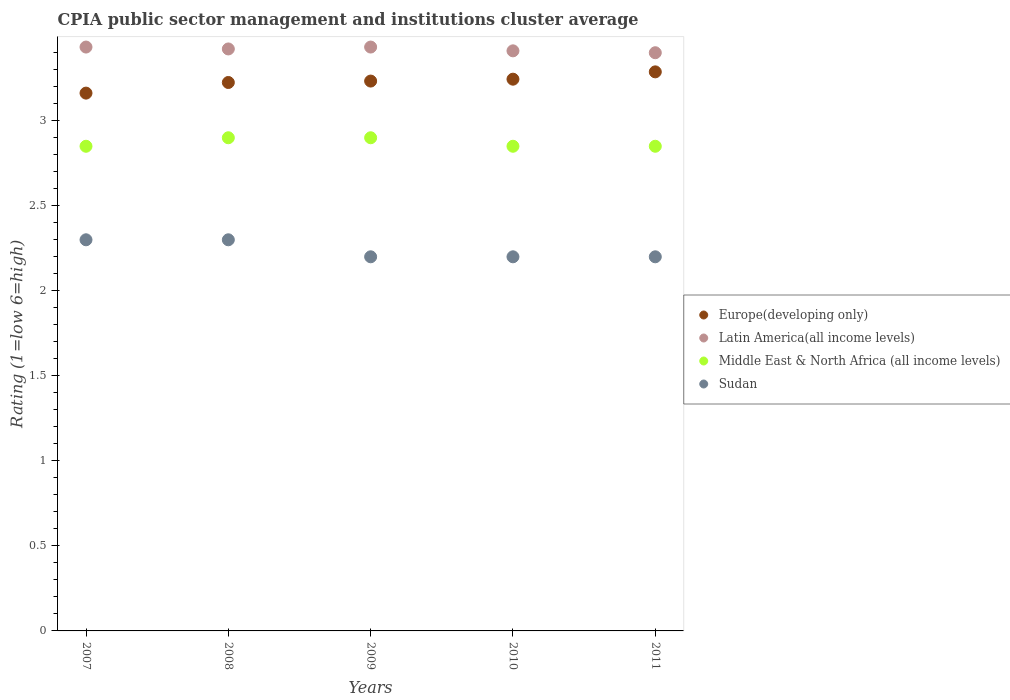How many different coloured dotlines are there?
Offer a very short reply. 4. Is the number of dotlines equal to the number of legend labels?
Your answer should be compact. Yes. Across all years, what is the maximum CPIA rating in Europe(developing only)?
Offer a very short reply. 3.29. Across all years, what is the minimum CPIA rating in Middle East & North Africa (all income levels)?
Make the answer very short. 2.85. In which year was the CPIA rating in Europe(developing only) maximum?
Provide a succinct answer. 2011. In which year was the CPIA rating in Latin America(all income levels) minimum?
Your answer should be very brief. 2011. What is the total CPIA rating in Sudan in the graph?
Your response must be concise. 11.2. What is the difference between the CPIA rating in Middle East & North Africa (all income levels) in 2009 and that in 2011?
Offer a terse response. 0.05. What is the difference between the CPIA rating in Middle East & North Africa (all income levels) in 2008 and the CPIA rating in Sudan in 2010?
Provide a succinct answer. 0.7. What is the average CPIA rating in Sudan per year?
Provide a succinct answer. 2.24. In the year 2009, what is the difference between the CPIA rating in Latin America(all income levels) and CPIA rating in Europe(developing only)?
Ensure brevity in your answer.  0.2. In how many years, is the CPIA rating in Middle East & North Africa (all income levels) greater than 2.7?
Keep it short and to the point. 5. What is the ratio of the CPIA rating in Sudan in 2007 to that in 2011?
Offer a very short reply. 1.05. Is the difference between the CPIA rating in Latin America(all income levels) in 2007 and 2010 greater than the difference between the CPIA rating in Europe(developing only) in 2007 and 2010?
Give a very brief answer. Yes. What is the difference between the highest and the second highest CPIA rating in Europe(developing only)?
Provide a short and direct response. 0.04. What is the difference between the highest and the lowest CPIA rating in Middle East & North Africa (all income levels)?
Ensure brevity in your answer.  0.05. Is it the case that in every year, the sum of the CPIA rating in Sudan and CPIA rating in Latin America(all income levels)  is greater than the sum of CPIA rating in Middle East & North Africa (all income levels) and CPIA rating in Europe(developing only)?
Provide a succinct answer. No. How many dotlines are there?
Your response must be concise. 4. How many years are there in the graph?
Give a very brief answer. 5. What is the difference between two consecutive major ticks on the Y-axis?
Your answer should be very brief. 0.5. Are the values on the major ticks of Y-axis written in scientific E-notation?
Provide a succinct answer. No. Does the graph contain grids?
Offer a terse response. No. Where does the legend appear in the graph?
Ensure brevity in your answer.  Center right. What is the title of the graph?
Give a very brief answer. CPIA public sector management and institutions cluster average. Does "Netherlands" appear as one of the legend labels in the graph?
Provide a short and direct response. No. What is the label or title of the X-axis?
Ensure brevity in your answer.  Years. What is the Rating (1=low 6=high) of Europe(developing only) in 2007?
Ensure brevity in your answer.  3.16. What is the Rating (1=low 6=high) in Latin America(all income levels) in 2007?
Keep it short and to the point. 3.43. What is the Rating (1=low 6=high) in Middle East & North Africa (all income levels) in 2007?
Give a very brief answer. 2.85. What is the Rating (1=low 6=high) in Sudan in 2007?
Ensure brevity in your answer.  2.3. What is the Rating (1=low 6=high) in Europe(developing only) in 2008?
Make the answer very short. 3.23. What is the Rating (1=low 6=high) in Latin America(all income levels) in 2008?
Make the answer very short. 3.42. What is the Rating (1=low 6=high) in Sudan in 2008?
Ensure brevity in your answer.  2.3. What is the Rating (1=low 6=high) in Europe(developing only) in 2009?
Your answer should be very brief. 3.23. What is the Rating (1=low 6=high) in Latin America(all income levels) in 2009?
Give a very brief answer. 3.43. What is the Rating (1=low 6=high) of Middle East & North Africa (all income levels) in 2009?
Your answer should be very brief. 2.9. What is the Rating (1=low 6=high) in Sudan in 2009?
Ensure brevity in your answer.  2.2. What is the Rating (1=low 6=high) in Europe(developing only) in 2010?
Your answer should be compact. 3.24. What is the Rating (1=low 6=high) in Latin America(all income levels) in 2010?
Your answer should be compact. 3.41. What is the Rating (1=low 6=high) of Middle East & North Africa (all income levels) in 2010?
Give a very brief answer. 2.85. What is the Rating (1=low 6=high) of Europe(developing only) in 2011?
Give a very brief answer. 3.29. What is the Rating (1=low 6=high) of Middle East & North Africa (all income levels) in 2011?
Your answer should be compact. 2.85. Across all years, what is the maximum Rating (1=low 6=high) of Europe(developing only)?
Offer a very short reply. 3.29. Across all years, what is the maximum Rating (1=low 6=high) of Latin America(all income levels)?
Your answer should be compact. 3.43. Across all years, what is the minimum Rating (1=low 6=high) of Europe(developing only)?
Give a very brief answer. 3.16. Across all years, what is the minimum Rating (1=low 6=high) in Latin America(all income levels)?
Offer a very short reply. 3.4. Across all years, what is the minimum Rating (1=low 6=high) in Middle East & North Africa (all income levels)?
Your answer should be very brief. 2.85. What is the total Rating (1=low 6=high) of Europe(developing only) in the graph?
Offer a terse response. 16.15. What is the total Rating (1=low 6=high) of Latin America(all income levels) in the graph?
Your response must be concise. 17.1. What is the total Rating (1=low 6=high) in Middle East & North Africa (all income levels) in the graph?
Offer a very short reply. 14.35. What is the total Rating (1=low 6=high) in Sudan in the graph?
Offer a terse response. 11.2. What is the difference between the Rating (1=low 6=high) in Europe(developing only) in 2007 and that in 2008?
Offer a terse response. -0.06. What is the difference between the Rating (1=low 6=high) in Latin America(all income levels) in 2007 and that in 2008?
Offer a very short reply. 0.01. What is the difference between the Rating (1=low 6=high) of Middle East & North Africa (all income levels) in 2007 and that in 2008?
Offer a very short reply. -0.05. What is the difference between the Rating (1=low 6=high) in Sudan in 2007 and that in 2008?
Provide a short and direct response. 0. What is the difference between the Rating (1=low 6=high) in Europe(developing only) in 2007 and that in 2009?
Your answer should be compact. -0.07. What is the difference between the Rating (1=low 6=high) in Middle East & North Africa (all income levels) in 2007 and that in 2009?
Your response must be concise. -0.05. What is the difference between the Rating (1=low 6=high) of Europe(developing only) in 2007 and that in 2010?
Keep it short and to the point. -0.08. What is the difference between the Rating (1=low 6=high) of Latin America(all income levels) in 2007 and that in 2010?
Give a very brief answer. 0.02. What is the difference between the Rating (1=low 6=high) in Middle East & North Africa (all income levels) in 2007 and that in 2010?
Your answer should be compact. 0. What is the difference between the Rating (1=low 6=high) in Sudan in 2007 and that in 2010?
Ensure brevity in your answer.  0.1. What is the difference between the Rating (1=low 6=high) of Europe(developing only) in 2007 and that in 2011?
Your response must be concise. -0.12. What is the difference between the Rating (1=low 6=high) of Latin America(all income levels) in 2007 and that in 2011?
Provide a short and direct response. 0.03. What is the difference between the Rating (1=low 6=high) of Sudan in 2007 and that in 2011?
Make the answer very short. 0.1. What is the difference between the Rating (1=low 6=high) of Europe(developing only) in 2008 and that in 2009?
Your answer should be compact. -0.01. What is the difference between the Rating (1=low 6=high) of Latin America(all income levels) in 2008 and that in 2009?
Offer a very short reply. -0.01. What is the difference between the Rating (1=low 6=high) of Middle East & North Africa (all income levels) in 2008 and that in 2009?
Keep it short and to the point. 0. What is the difference between the Rating (1=low 6=high) of Sudan in 2008 and that in 2009?
Your response must be concise. 0.1. What is the difference between the Rating (1=low 6=high) in Europe(developing only) in 2008 and that in 2010?
Give a very brief answer. -0.02. What is the difference between the Rating (1=low 6=high) in Latin America(all income levels) in 2008 and that in 2010?
Your answer should be very brief. 0.01. What is the difference between the Rating (1=low 6=high) in Middle East & North Africa (all income levels) in 2008 and that in 2010?
Keep it short and to the point. 0.05. What is the difference between the Rating (1=low 6=high) of Europe(developing only) in 2008 and that in 2011?
Your response must be concise. -0.06. What is the difference between the Rating (1=low 6=high) of Latin America(all income levels) in 2008 and that in 2011?
Your answer should be compact. 0.02. What is the difference between the Rating (1=low 6=high) in Middle East & North Africa (all income levels) in 2008 and that in 2011?
Your answer should be compact. 0.05. What is the difference between the Rating (1=low 6=high) in Sudan in 2008 and that in 2011?
Make the answer very short. 0.1. What is the difference between the Rating (1=low 6=high) in Europe(developing only) in 2009 and that in 2010?
Make the answer very short. -0.01. What is the difference between the Rating (1=low 6=high) of Latin America(all income levels) in 2009 and that in 2010?
Offer a very short reply. 0.02. What is the difference between the Rating (1=low 6=high) of Sudan in 2009 and that in 2010?
Your answer should be compact. 0. What is the difference between the Rating (1=low 6=high) in Europe(developing only) in 2009 and that in 2011?
Keep it short and to the point. -0.05. What is the difference between the Rating (1=low 6=high) of Latin America(all income levels) in 2009 and that in 2011?
Your answer should be very brief. 0.03. What is the difference between the Rating (1=low 6=high) in Middle East & North Africa (all income levels) in 2009 and that in 2011?
Offer a very short reply. 0.05. What is the difference between the Rating (1=low 6=high) in Sudan in 2009 and that in 2011?
Your response must be concise. 0. What is the difference between the Rating (1=low 6=high) of Europe(developing only) in 2010 and that in 2011?
Provide a succinct answer. -0.04. What is the difference between the Rating (1=low 6=high) of Latin America(all income levels) in 2010 and that in 2011?
Provide a succinct answer. 0.01. What is the difference between the Rating (1=low 6=high) in Europe(developing only) in 2007 and the Rating (1=low 6=high) in Latin America(all income levels) in 2008?
Your answer should be very brief. -0.26. What is the difference between the Rating (1=low 6=high) of Europe(developing only) in 2007 and the Rating (1=low 6=high) of Middle East & North Africa (all income levels) in 2008?
Your answer should be compact. 0.26. What is the difference between the Rating (1=low 6=high) in Europe(developing only) in 2007 and the Rating (1=low 6=high) in Sudan in 2008?
Make the answer very short. 0.86. What is the difference between the Rating (1=low 6=high) in Latin America(all income levels) in 2007 and the Rating (1=low 6=high) in Middle East & North Africa (all income levels) in 2008?
Provide a succinct answer. 0.53. What is the difference between the Rating (1=low 6=high) of Latin America(all income levels) in 2007 and the Rating (1=low 6=high) of Sudan in 2008?
Your answer should be very brief. 1.13. What is the difference between the Rating (1=low 6=high) in Middle East & North Africa (all income levels) in 2007 and the Rating (1=low 6=high) in Sudan in 2008?
Offer a terse response. 0.55. What is the difference between the Rating (1=low 6=high) in Europe(developing only) in 2007 and the Rating (1=low 6=high) in Latin America(all income levels) in 2009?
Ensure brevity in your answer.  -0.27. What is the difference between the Rating (1=low 6=high) in Europe(developing only) in 2007 and the Rating (1=low 6=high) in Middle East & North Africa (all income levels) in 2009?
Ensure brevity in your answer.  0.26. What is the difference between the Rating (1=low 6=high) of Europe(developing only) in 2007 and the Rating (1=low 6=high) of Sudan in 2009?
Keep it short and to the point. 0.96. What is the difference between the Rating (1=low 6=high) in Latin America(all income levels) in 2007 and the Rating (1=low 6=high) in Middle East & North Africa (all income levels) in 2009?
Provide a succinct answer. 0.53. What is the difference between the Rating (1=low 6=high) in Latin America(all income levels) in 2007 and the Rating (1=low 6=high) in Sudan in 2009?
Give a very brief answer. 1.23. What is the difference between the Rating (1=low 6=high) in Middle East & North Africa (all income levels) in 2007 and the Rating (1=low 6=high) in Sudan in 2009?
Provide a succinct answer. 0.65. What is the difference between the Rating (1=low 6=high) in Europe(developing only) in 2007 and the Rating (1=low 6=high) in Latin America(all income levels) in 2010?
Provide a short and direct response. -0.25. What is the difference between the Rating (1=low 6=high) of Europe(developing only) in 2007 and the Rating (1=low 6=high) of Middle East & North Africa (all income levels) in 2010?
Your response must be concise. 0.31. What is the difference between the Rating (1=low 6=high) of Europe(developing only) in 2007 and the Rating (1=low 6=high) of Sudan in 2010?
Offer a terse response. 0.96. What is the difference between the Rating (1=low 6=high) in Latin America(all income levels) in 2007 and the Rating (1=low 6=high) in Middle East & North Africa (all income levels) in 2010?
Your answer should be compact. 0.58. What is the difference between the Rating (1=low 6=high) in Latin America(all income levels) in 2007 and the Rating (1=low 6=high) in Sudan in 2010?
Provide a succinct answer. 1.23. What is the difference between the Rating (1=low 6=high) of Middle East & North Africa (all income levels) in 2007 and the Rating (1=low 6=high) of Sudan in 2010?
Keep it short and to the point. 0.65. What is the difference between the Rating (1=low 6=high) in Europe(developing only) in 2007 and the Rating (1=low 6=high) in Latin America(all income levels) in 2011?
Keep it short and to the point. -0.24. What is the difference between the Rating (1=low 6=high) of Europe(developing only) in 2007 and the Rating (1=low 6=high) of Middle East & North Africa (all income levels) in 2011?
Your answer should be very brief. 0.31. What is the difference between the Rating (1=low 6=high) in Europe(developing only) in 2007 and the Rating (1=low 6=high) in Sudan in 2011?
Provide a short and direct response. 0.96. What is the difference between the Rating (1=low 6=high) of Latin America(all income levels) in 2007 and the Rating (1=low 6=high) of Middle East & North Africa (all income levels) in 2011?
Your answer should be very brief. 0.58. What is the difference between the Rating (1=low 6=high) in Latin America(all income levels) in 2007 and the Rating (1=low 6=high) in Sudan in 2011?
Your response must be concise. 1.23. What is the difference between the Rating (1=low 6=high) of Middle East & North Africa (all income levels) in 2007 and the Rating (1=low 6=high) of Sudan in 2011?
Give a very brief answer. 0.65. What is the difference between the Rating (1=low 6=high) of Europe(developing only) in 2008 and the Rating (1=low 6=high) of Latin America(all income levels) in 2009?
Your response must be concise. -0.21. What is the difference between the Rating (1=low 6=high) in Europe(developing only) in 2008 and the Rating (1=low 6=high) in Middle East & North Africa (all income levels) in 2009?
Provide a succinct answer. 0.33. What is the difference between the Rating (1=low 6=high) of Europe(developing only) in 2008 and the Rating (1=low 6=high) of Sudan in 2009?
Your response must be concise. 1.02. What is the difference between the Rating (1=low 6=high) in Latin America(all income levels) in 2008 and the Rating (1=low 6=high) in Middle East & North Africa (all income levels) in 2009?
Your response must be concise. 0.52. What is the difference between the Rating (1=low 6=high) in Latin America(all income levels) in 2008 and the Rating (1=low 6=high) in Sudan in 2009?
Give a very brief answer. 1.22. What is the difference between the Rating (1=low 6=high) in Middle East & North Africa (all income levels) in 2008 and the Rating (1=low 6=high) in Sudan in 2009?
Offer a very short reply. 0.7. What is the difference between the Rating (1=low 6=high) of Europe(developing only) in 2008 and the Rating (1=low 6=high) of Latin America(all income levels) in 2010?
Provide a succinct answer. -0.19. What is the difference between the Rating (1=low 6=high) of Latin America(all income levels) in 2008 and the Rating (1=low 6=high) of Middle East & North Africa (all income levels) in 2010?
Provide a succinct answer. 0.57. What is the difference between the Rating (1=low 6=high) in Latin America(all income levels) in 2008 and the Rating (1=low 6=high) in Sudan in 2010?
Provide a short and direct response. 1.22. What is the difference between the Rating (1=low 6=high) in Europe(developing only) in 2008 and the Rating (1=low 6=high) in Latin America(all income levels) in 2011?
Offer a terse response. -0.17. What is the difference between the Rating (1=low 6=high) in Europe(developing only) in 2008 and the Rating (1=low 6=high) in Middle East & North Africa (all income levels) in 2011?
Make the answer very short. 0.38. What is the difference between the Rating (1=low 6=high) of Latin America(all income levels) in 2008 and the Rating (1=low 6=high) of Middle East & North Africa (all income levels) in 2011?
Keep it short and to the point. 0.57. What is the difference between the Rating (1=low 6=high) in Latin America(all income levels) in 2008 and the Rating (1=low 6=high) in Sudan in 2011?
Offer a very short reply. 1.22. What is the difference between the Rating (1=low 6=high) of Middle East & North Africa (all income levels) in 2008 and the Rating (1=low 6=high) of Sudan in 2011?
Ensure brevity in your answer.  0.7. What is the difference between the Rating (1=low 6=high) in Europe(developing only) in 2009 and the Rating (1=low 6=high) in Latin America(all income levels) in 2010?
Provide a succinct answer. -0.18. What is the difference between the Rating (1=low 6=high) of Europe(developing only) in 2009 and the Rating (1=low 6=high) of Middle East & North Africa (all income levels) in 2010?
Your response must be concise. 0.38. What is the difference between the Rating (1=low 6=high) of Europe(developing only) in 2009 and the Rating (1=low 6=high) of Sudan in 2010?
Your answer should be very brief. 1.03. What is the difference between the Rating (1=low 6=high) of Latin America(all income levels) in 2009 and the Rating (1=low 6=high) of Middle East & North Africa (all income levels) in 2010?
Provide a succinct answer. 0.58. What is the difference between the Rating (1=low 6=high) of Latin America(all income levels) in 2009 and the Rating (1=low 6=high) of Sudan in 2010?
Give a very brief answer. 1.23. What is the difference between the Rating (1=low 6=high) of Europe(developing only) in 2009 and the Rating (1=low 6=high) of Latin America(all income levels) in 2011?
Keep it short and to the point. -0.17. What is the difference between the Rating (1=low 6=high) of Europe(developing only) in 2009 and the Rating (1=low 6=high) of Middle East & North Africa (all income levels) in 2011?
Provide a succinct answer. 0.38. What is the difference between the Rating (1=low 6=high) of Europe(developing only) in 2009 and the Rating (1=low 6=high) of Sudan in 2011?
Ensure brevity in your answer.  1.03. What is the difference between the Rating (1=low 6=high) of Latin America(all income levels) in 2009 and the Rating (1=low 6=high) of Middle East & North Africa (all income levels) in 2011?
Give a very brief answer. 0.58. What is the difference between the Rating (1=low 6=high) of Latin America(all income levels) in 2009 and the Rating (1=low 6=high) of Sudan in 2011?
Make the answer very short. 1.23. What is the difference between the Rating (1=low 6=high) of Middle East & North Africa (all income levels) in 2009 and the Rating (1=low 6=high) of Sudan in 2011?
Provide a succinct answer. 0.7. What is the difference between the Rating (1=low 6=high) of Europe(developing only) in 2010 and the Rating (1=low 6=high) of Latin America(all income levels) in 2011?
Offer a terse response. -0.16. What is the difference between the Rating (1=low 6=high) of Europe(developing only) in 2010 and the Rating (1=low 6=high) of Middle East & North Africa (all income levels) in 2011?
Provide a succinct answer. 0.39. What is the difference between the Rating (1=low 6=high) of Europe(developing only) in 2010 and the Rating (1=low 6=high) of Sudan in 2011?
Your answer should be very brief. 1.04. What is the difference between the Rating (1=low 6=high) of Latin America(all income levels) in 2010 and the Rating (1=low 6=high) of Middle East & North Africa (all income levels) in 2011?
Provide a succinct answer. 0.56. What is the difference between the Rating (1=low 6=high) in Latin America(all income levels) in 2010 and the Rating (1=low 6=high) in Sudan in 2011?
Provide a succinct answer. 1.21. What is the difference between the Rating (1=low 6=high) in Middle East & North Africa (all income levels) in 2010 and the Rating (1=low 6=high) in Sudan in 2011?
Keep it short and to the point. 0.65. What is the average Rating (1=low 6=high) of Europe(developing only) per year?
Give a very brief answer. 3.23. What is the average Rating (1=low 6=high) of Latin America(all income levels) per year?
Give a very brief answer. 3.42. What is the average Rating (1=low 6=high) of Middle East & North Africa (all income levels) per year?
Give a very brief answer. 2.87. What is the average Rating (1=low 6=high) in Sudan per year?
Keep it short and to the point. 2.24. In the year 2007, what is the difference between the Rating (1=low 6=high) in Europe(developing only) and Rating (1=low 6=high) in Latin America(all income levels)?
Keep it short and to the point. -0.27. In the year 2007, what is the difference between the Rating (1=low 6=high) of Europe(developing only) and Rating (1=low 6=high) of Middle East & North Africa (all income levels)?
Offer a terse response. 0.31. In the year 2007, what is the difference between the Rating (1=low 6=high) of Europe(developing only) and Rating (1=low 6=high) of Sudan?
Offer a terse response. 0.86. In the year 2007, what is the difference between the Rating (1=low 6=high) in Latin America(all income levels) and Rating (1=low 6=high) in Middle East & North Africa (all income levels)?
Ensure brevity in your answer.  0.58. In the year 2007, what is the difference between the Rating (1=low 6=high) in Latin America(all income levels) and Rating (1=low 6=high) in Sudan?
Offer a very short reply. 1.13. In the year 2007, what is the difference between the Rating (1=low 6=high) in Middle East & North Africa (all income levels) and Rating (1=low 6=high) in Sudan?
Offer a terse response. 0.55. In the year 2008, what is the difference between the Rating (1=low 6=high) of Europe(developing only) and Rating (1=low 6=high) of Latin America(all income levels)?
Your answer should be very brief. -0.2. In the year 2008, what is the difference between the Rating (1=low 6=high) in Europe(developing only) and Rating (1=low 6=high) in Middle East & North Africa (all income levels)?
Give a very brief answer. 0.33. In the year 2008, what is the difference between the Rating (1=low 6=high) of Europe(developing only) and Rating (1=low 6=high) of Sudan?
Keep it short and to the point. 0.93. In the year 2008, what is the difference between the Rating (1=low 6=high) of Latin America(all income levels) and Rating (1=low 6=high) of Middle East & North Africa (all income levels)?
Ensure brevity in your answer.  0.52. In the year 2008, what is the difference between the Rating (1=low 6=high) of Latin America(all income levels) and Rating (1=low 6=high) of Sudan?
Your response must be concise. 1.12. In the year 2009, what is the difference between the Rating (1=low 6=high) of Europe(developing only) and Rating (1=low 6=high) of Latin America(all income levels)?
Provide a short and direct response. -0.2. In the year 2009, what is the difference between the Rating (1=low 6=high) of Europe(developing only) and Rating (1=low 6=high) of Middle East & North Africa (all income levels)?
Provide a succinct answer. 0.33. In the year 2009, what is the difference between the Rating (1=low 6=high) in Europe(developing only) and Rating (1=low 6=high) in Sudan?
Offer a terse response. 1.03. In the year 2009, what is the difference between the Rating (1=low 6=high) in Latin America(all income levels) and Rating (1=low 6=high) in Middle East & North Africa (all income levels)?
Your answer should be very brief. 0.53. In the year 2009, what is the difference between the Rating (1=low 6=high) in Latin America(all income levels) and Rating (1=low 6=high) in Sudan?
Make the answer very short. 1.23. In the year 2009, what is the difference between the Rating (1=low 6=high) of Middle East & North Africa (all income levels) and Rating (1=low 6=high) of Sudan?
Your answer should be compact. 0.7. In the year 2010, what is the difference between the Rating (1=low 6=high) in Europe(developing only) and Rating (1=low 6=high) in Latin America(all income levels)?
Offer a terse response. -0.17. In the year 2010, what is the difference between the Rating (1=low 6=high) of Europe(developing only) and Rating (1=low 6=high) of Middle East & North Africa (all income levels)?
Your answer should be compact. 0.39. In the year 2010, what is the difference between the Rating (1=low 6=high) of Europe(developing only) and Rating (1=low 6=high) of Sudan?
Your answer should be very brief. 1.04. In the year 2010, what is the difference between the Rating (1=low 6=high) of Latin America(all income levels) and Rating (1=low 6=high) of Middle East & North Africa (all income levels)?
Provide a short and direct response. 0.56. In the year 2010, what is the difference between the Rating (1=low 6=high) of Latin America(all income levels) and Rating (1=low 6=high) of Sudan?
Keep it short and to the point. 1.21. In the year 2010, what is the difference between the Rating (1=low 6=high) in Middle East & North Africa (all income levels) and Rating (1=low 6=high) in Sudan?
Ensure brevity in your answer.  0.65. In the year 2011, what is the difference between the Rating (1=low 6=high) in Europe(developing only) and Rating (1=low 6=high) in Latin America(all income levels)?
Provide a succinct answer. -0.11. In the year 2011, what is the difference between the Rating (1=low 6=high) of Europe(developing only) and Rating (1=low 6=high) of Middle East & North Africa (all income levels)?
Provide a succinct answer. 0.44. In the year 2011, what is the difference between the Rating (1=low 6=high) in Europe(developing only) and Rating (1=low 6=high) in Sudan?
Your answer should be very brief. 1.09. In the year 2011, what is the difference between the Rating (1=low 6=high) in Latin America(all income levels) and Rating (1=low 6=high) in Middle East & North Africa (all income levels)?
Keep it short and to the point. 0.55. In the year 2011, what is the difference between the Rating (1=low 6=high) of Latin America(all income levels) and Rating (1=low 6=high) of Sudan?
Your answer should be very brief. 1.2. In the year 2011, what is the difference between the Rating (1=low 6=high) of Middle East & North Africa (all income levels) and Rating (1=low 6=high) of Sudan?
Offer a very short reply. 0.65. What is the ratio of the Rating (1=low 6=high) of Europe(developing only) in 2007 to that in 2008?
Provide a short and direct response. 0.98. What is the ratio of the Rating (1=low 6=high) of Latin America(all income levels) in 2007 to that in 2008?
Your answer should be compact. 1. What is the ratio of the Rating (1=low 6=high) of Middle East & North Africa (all income levels) in 2007 to that in 2008?
Provide a succinct answer. 0.98. What is the ratio of the Rating (1=low 6=high) of Europe(developing only) in 2007 to that in 2009?
Your response must be concise. 0.98. What is the ratio of the Rating (1=low 6=high) in Middle East & North Africa (all income levels) in 2007 to that in 2009?
Your answer should be very brief. 0.98. What is the ratio of the Rating (1=low 6=high) in Sudan in 2007 to that in 2009?
Provide a succinct answer. 1.05. What is the ratio of the Rating (1=low 6=high) in Europe(developing only) in 2007 to that in 2010?
Keep it short and to the point. 0.97. What is the ratio of the Rating (1=low 6=high) of Sudan in 2007 to that in 2010?
Your answer should be very brief. 1.05. What is the ratio of the Rating (1=low 6=high) in Europe(developing only) in 2007 to that in 2011?
Provide a succinct answer. 0.96. What is the ratio of the Rating (1=low 6=high) of Latin America(all income levels) in 2007 to that in 2011?
Your response must be concise. 1.01. What is the ratio of the Rating (1=low 6=high) in Sudan in 2007 to that in 2011?
Ensure brevity in your answer.  1.05. What is the ratio of the Rating (1=low 6=high) in Sudan in 2008 to that in 2009?
Keep it short and to the point. 1.05. What is the ratio of the Rating (1=low 6=high) of Europe(developing only) in 2008 to that in 2010?
Give a very brief answer. 0.99. What is the ratio of the Rating (1=low 6=high) in Latin America(all income levels) in 2008 to that in 2010?
Your answer should be very brief. 1. What is the ratio of the Rating (1=low 6=high) of Middle East & North Africa (all income levels) in 2008 to that in 2010?
Give a very brief answer. 1.02. What is the ratio of the Rating (1=low 6=high) of Sudan in 2008 to that in 2010?
Your answer should be compact. 1.05. What is the ratio of the Rating (1=low 6=high) in Latin America(all income levels) in 2008 to that in 2011?
Your answer should be compact. 1.01. What is the ratio of the Rating (1=low 6=high) in Middle East & North Africa (all income levels) in 2008 to that in 2011?
Offer a very short reply. 1.02. What is the ratio of the Rating (1=low 6=high) in Sudan in 2008 to that in 2011?
Your answer should be compact. 1.05. What is the ratio of the Rating (1=low 6=high) in Europe(developing only) in 2009 to that in 2010?
Your answer should be very brief. 1. What is the ratio of the Rating (1=low 6=high) of Latin America(all income levels) in 2009 to that in 2010?
Give a very brief answer. 1.01. What is the ratio of the Rating (1=low 6=high) of Middle East & North Africa (all income levels) in 2009 to that in 2010?
Your answer should be compact. 1.02. What is the ratio of the Rating (1=low 6=high) of Europe(developing only) in 2009 to that in 2011?
Ensure brevity in your answer.  0.98. What is the ratio of the Rating (1=low 6=high) of Latin America(all income levels) in 2009 to that in 2011?
Make the answer very short. 1.01. What is the ratio of the Rating (1=low 6=high) in Middle East & North Africa (all income levels) in 2009 to that in 2011?
Your response must be concise. 1.02. What is the ratio of the Rating (1=low 6=high) in Europe(developing only) in 2010 to that in 2011?
Offer a very short reply. 0.99. What is the ratio of the Rating (1=low 6=high) in Sudan in 2010 to that in 2011?
Provide a short and direct response. 1. What is the difference between the highest and the second highest Rating (1=low 6=high) of Europe(developing only)?
Make the answer very short. 0.04. What is the difference between the highest and the second highest Rating (1=low 6=high) of Middle East & North Africa (all income levels)?
Offer a terse response. 0. What is the difference between the highest and the second highest Rating (1=low 6=high) of Sudan?
Provide a succinct answer. 0. What is the difference between the highest and the lowest Rating (1=low 6=high) in Middle East & North Africa (all income levels)?
Provide a succinct answer. 0.05. 